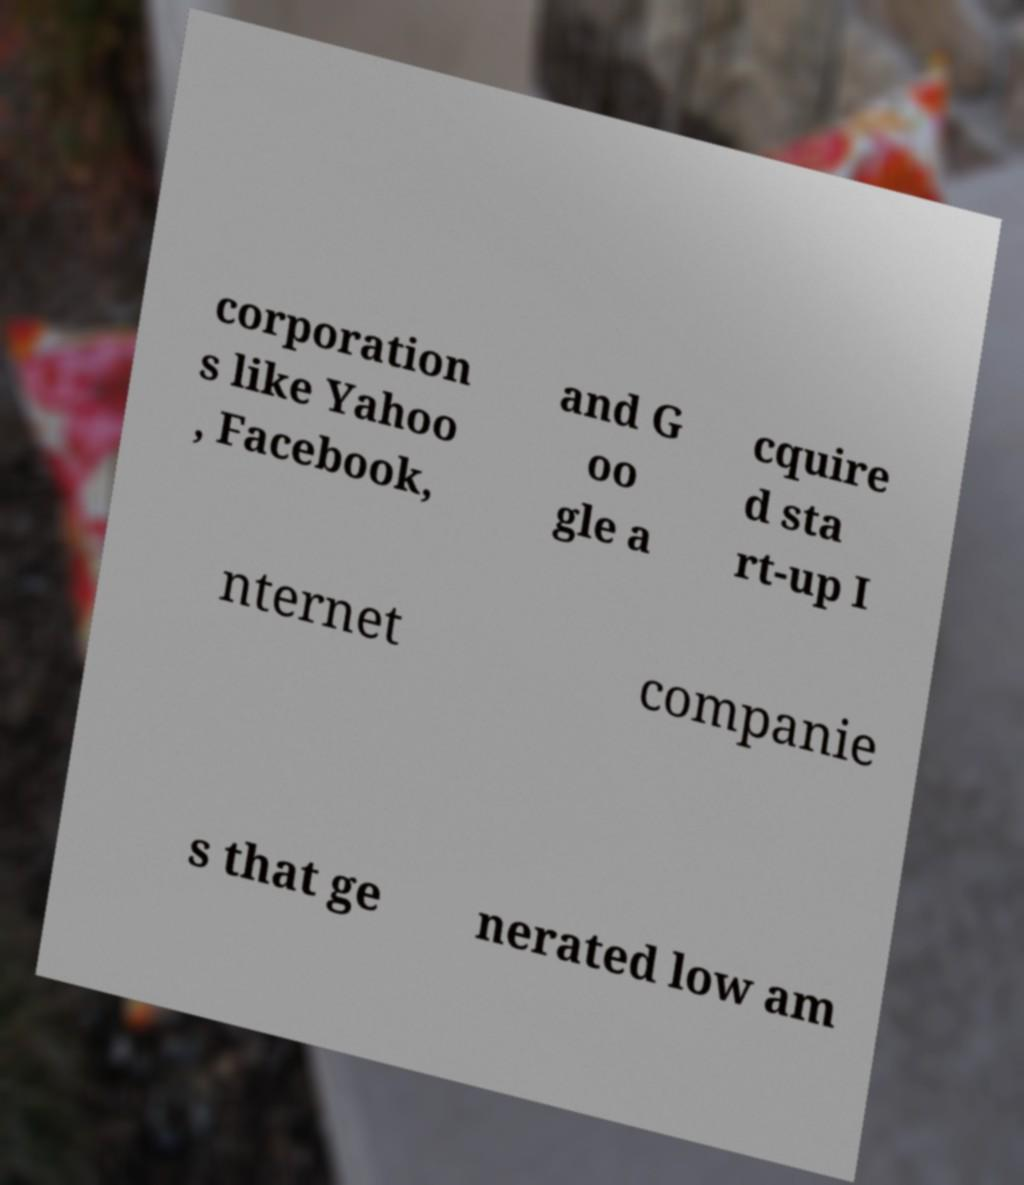Can you read and provide the text displayed in the image?This photo seems to have some interesting text. Can you extract and type it out for me? corporation s like Yahoo , Facebook, and G oo gle a cquire d sta rt-up I nternet companie s that ge nerated low am 